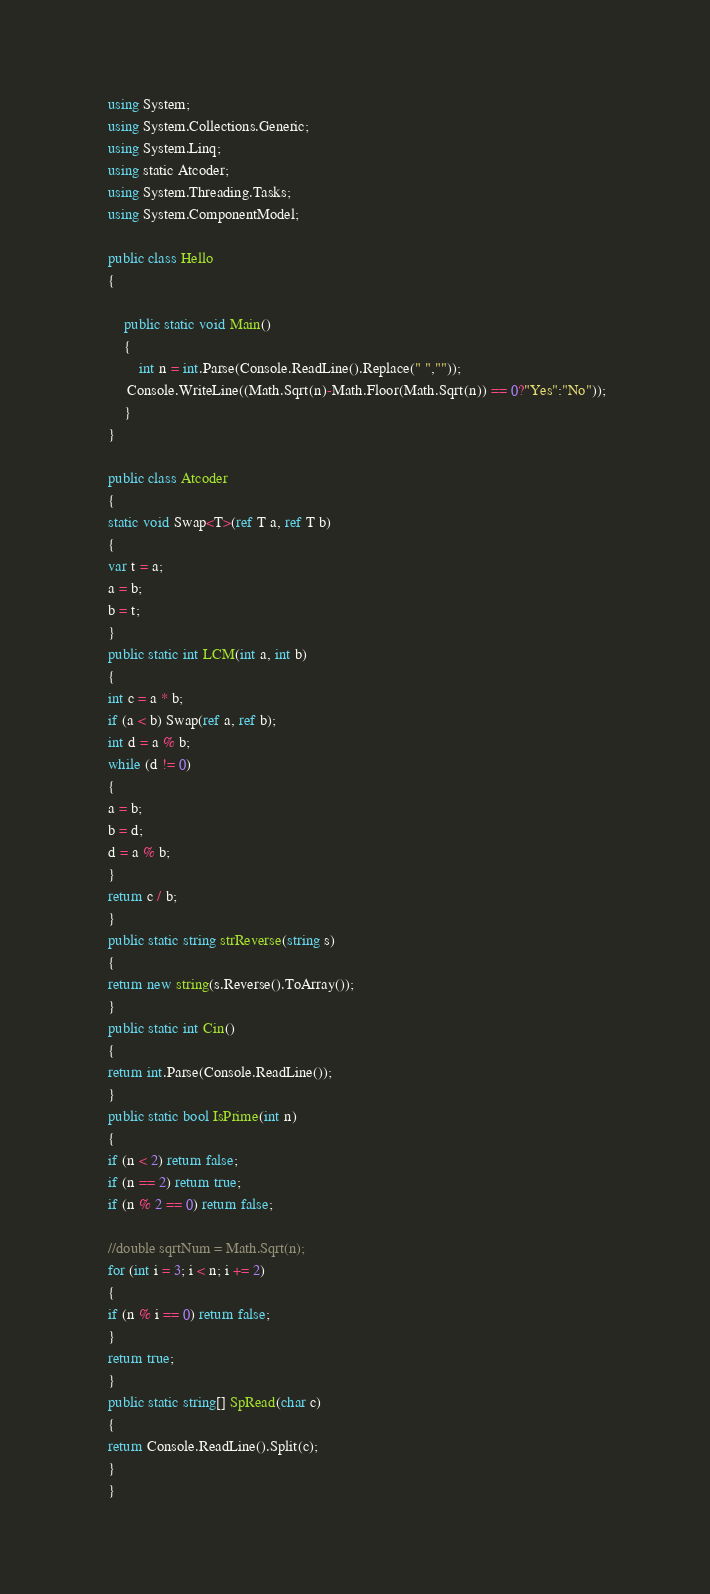<code> <loc_0><loc_0><loc_500><loc_500><_C#_>    using System;
    using System.Collections.Generic;
    using System.Linq;
    using static Atcoder;
    using System.Threading.Tasks;
    using System.ComponentModel;
     
    public class Hello
    {
     
        public static void Main()
        {
            int n = int.Parse(Console.ReadLine().Replace(" ",""));
         Console.WriteLine((Math.Sqrt(n)-Math.Floor(Math.Sqrt(n)) == 0?"Yes":"No"));   
        }
    }
     
    public class Atcoder
    {
    static void Swap<T>(ref T a, ref T b)
    {
    var t = a;
    a = b;
    b = t;
    }
    public static int LCM(int a, int b)
    {
    int c = a * b;
    if (a < b) Swap(ref a, ref b);
    int d = a % b;
    while (d != 0)
    {
    a = b;
    b = d;
    d = a % b;
    }
    return c / b;
    }
    public static string strReverse(string s)
    {
    return new string(s.Reverse().ToArray());
    }
    public static int Cin()
    {
    return int.Parse(Console.ReadLine());
    }
    public static bool IsPrime(int n)
    {
    if (n < 2) return false;
    if (n == 2) return true;
    if (n % 2 == 0) return false;
     
    //double sqrtNum = Math.Sqrt(n);
    for (int i = 3; i < n; i += 2)
    {
    if (n % i == 0) return false;
    }
    return true;
    }
    public static string[] SpRead(char c)
    {
    return Console.ReadLine().Split(c);
    }
    }</code> 